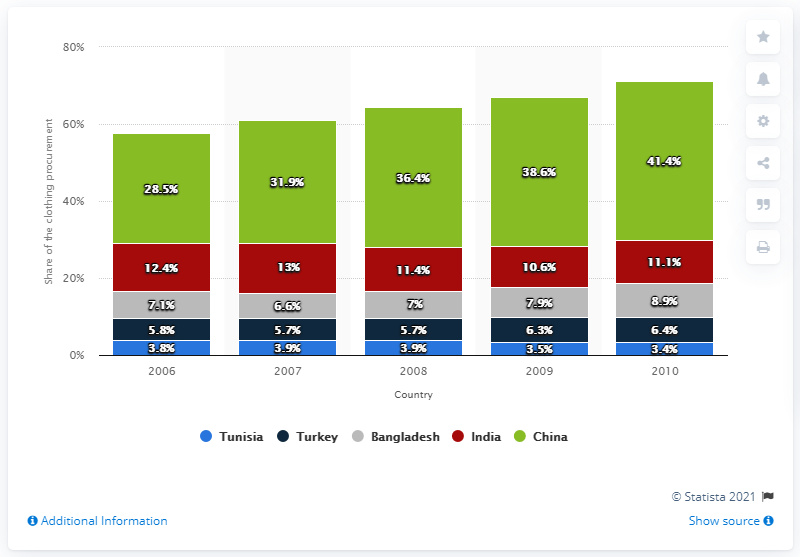Draw attention to some important aspects in this diagram. In 2009, approximately 6.3% of clothing sold in the European Union was manufactured in Turkey. 